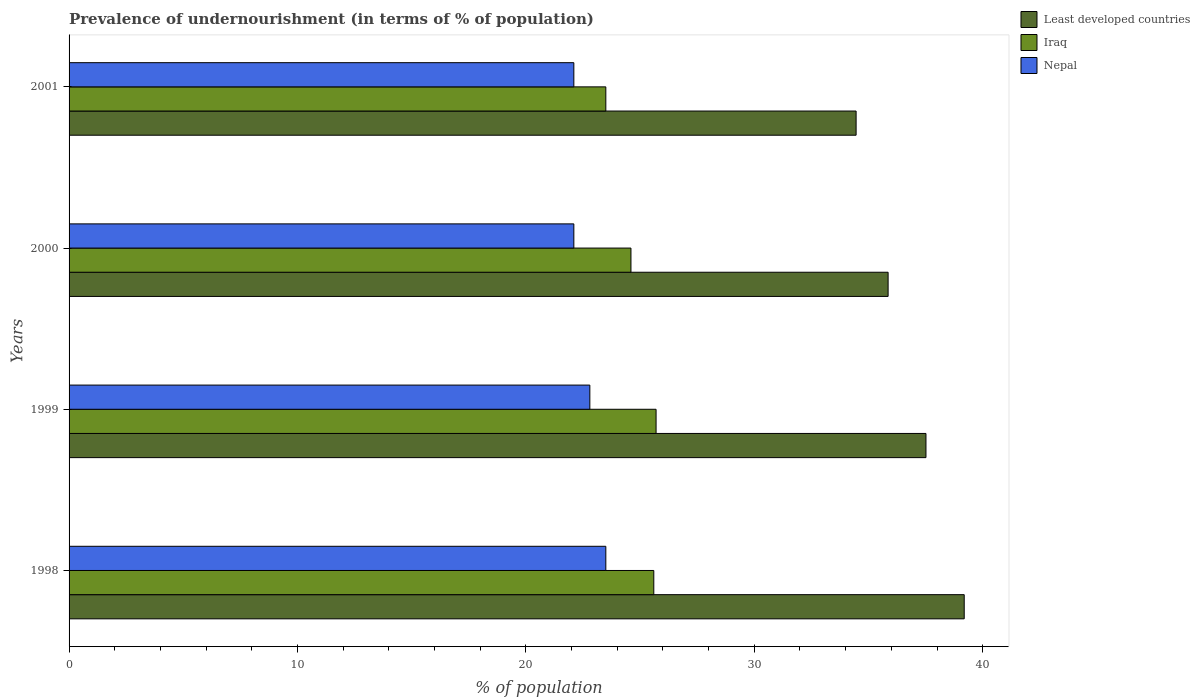Are the number of bars per tick equal to the number of legend labels?
Your answer should be compact. Yes. Are the number of bars on each tick of the Y-axis equal?
Offer a very short reply. Yes. How many bars are there on the 3rd tick from the bottom?
Your answer should be very brief. 3. What is the label of the 1st group of bars from the top?
Your answer should be very brief. 2001. What is the percentage of undernourished population in Iraq in 2000?
Your answer should be very brief. 24.6. Across all years, what is the maximum percentage of undernourished population in Iraq?
Offer a terse response. 25.7. Across all years, what is the minimum percentage of undernourished population in Nepal?
Ensure brevity in your answer.  22.1. What is the total percentage of undernourished population in Least developed countries in the graph?
Keep it short and to the point. 147.02. What is the difference between the percentage of undernourished population in Iraq in 1999 and that in 2000?
Your answer should be compact. 1.1. What is the difference between the percentage of undernourished population in Iraq in 2000 and the percentage of undernourished population in Least developed countries in 1999?
Give a very brief answer. -12.92. What is the average percentage of undernourished population in Nepal per year?
Your response must be concise. 22.62. In the year 1999, what is the difference between the percentage of undernourished population in Nepal and percentage of undernourished population in Iraq?
Make the answer very short. -2.9. What is the ratio of the percentage of undernourished population in Iraq in 1998 to that in 2000?
Your answer should be compact. 1.04. What is the difference between the highest and the second highest percentage of undernourished population in Nepal?
Make the answer very short. 0.7. What is the difference between the highest and the lowest percentage of undernourished population in Iraq?
Provide a short and direct response. 2.2. In how many years, is the percentage of undernourished population in Least developed countries greater than the average percentage of undernourished population in Least developed countries taken over all years?
Make the answer very short. 2. What does the 2nd bar from the top in 2001 represents?
Keep it short and to the point. Iraq. What does the 1st bar from the bottom in 2000 represents?
Offer a terse response. Least developed countries. How many bars are there?
Offer a terse response. 12. Are the values on the major ticks of X-axis written in scientific E-notation?
Your answer should be compact. No. Does the graph contain grids?
Your answer should be compact. No. Where does the legend appear in the graph?
Your response must be concise. Top right. What is the title of the graph?
Give a very brief answer. Prevalence of undernourishment (in terms of % of population). Does "Armenia" appear as one of the legend labels in the graph?
Offer a very short reply. No. What is the label or title of the X-axis?
Provide a short and direct response. % of population. What is the label or title of the Y-axis?
Offer a very short reply. Years. What is the % of population in Least developed countries in 1998?
Provide a short and direct response. 39.19. What is the % of population in Iraq in 1998?
Your answer should be compact. 25.6. What is the % of population in Nepal in 1998?
Make the answer very short. 23.5. What is the % of population in Least developed countries in 1999?
Provide a succinct answer. 37.52. What is the % of population in Iraq in 1999?
Offer a very short reply. 25.7. What is the % of population in Nepal in 1999?
Provide a succinct answer. 22.8. What is the % of population of Least developed countries in 2000?
Provide a succinct answer. 35.86. What is the % of population of Iraq in 2000?
Provide a short and direct response. 24.6. What is the % of population in Nepal in 2000?
Your answer should be very brief. 22.1. What is the % of population in Least developed countries in 2001?
Ensure brevity in your answer.  34.46. What is the % of population in Iraq in 2001?
Keep it short and to the point. 23.5. What is the % of population in Nepal in 2001?
Offer a very short reply. 22.1. Across all years, what is the maximum % of population of Least developed countries?
Keep it short and to the point. 39.19. Across all years, what is the maximum % of population of Iraq?
Offer a very short reply. 25.7. Across all years, what is the maximum % of population of Nepal?
Your response must be concise. 23.5. Across all years, what is the minimum % of population of Least developed countries?
Provide a succinct answer. 34.46. Across all years, what is the minimum % of population of Nepal?
Make the answer very short. 22.1. What is the total % of population of Least developed countries in the graph?
Your answer should be compact. 147.02. What is the total % of population in Iraq in the graph?
Offer a terse response. 99.4. What is the total % of population of Nepal in the graph?
Your answer should be compact. 90.5. What is the difference between the % of population of Least developed countries in 1998 and that in 1999?
Make the answer very short. 1.67. What is the difference between the % of population in Iraq in 1998 and that in 1999?
Offer a very short reply. -0.1. What is the difference between the % of population in Nepal in 1998 and that in 1999?
Your response must be concise. 0.7. What is the difference between the % of population of Least developed countries in 1998 and that in 2000?
Offer a very short reply. 3.33. What is the difference between the % of population of Nepal in 1998 and that in 2000?
Offer a terse response. 1.4. What is the difference between the % of population in Least developed countries in 1998 and that in 2001?
Your answer should be very brief. 4.73. What is the difference between the % of population in Nepal in 1998 and that in 2001?
Offer a very short reply. 1.4. What is the difference between the % of population in Least developed countries in 1999 and that in 2000?
Make the answer very short. 1.66. What is the difference between the % of population of Iraq in 1999 and that in 2000?
Make the answer very short. 1.1. What is the difference between the % of population in Nepal in 1999 and that in 2000?
Provide a succinct answer. 0.7. What is the difference between the % of population of Least developed countries in 1999 and that in 2001?
Your answer should be compact. 3.06. What is the difference between the % of population in Nepal in 1999 and that in 2001?
Offer a terse response. 0.7. What is the difference between the % of population of Least developed countries in 2000 and that in 2001?
Give a very brief answer. 1.4. What is the difference between the % of population in Least developed countries in 1998 and the % of population in Iraq in 1999?
Offer a very short reply. 13.49. What is the difference between the % of population of Least developed countries in 1998 and the % of population of Nepal in 1999?
Keep it short and to the point. 16.39. What is the difference between the % of population of Least developed countries in 1998 and the % of population of Iraq in 2000?
Give a very brief answer. 14.59. What is the difference between the % of population of Least developed countries in 1998 and the % of population of Nepal in 2000?
Provide a succinct answer. 17.09. What is the difference between the % of population of Least developed countries in 1998 and the % of population of Iraq in 2001?
Ensure brevity in your answer.  15.69. What is the difference between the % of population of Least developed countries in 1998 and the % of population of Nepal in 2001?
Give a very brief answer. 17.09. What is the difference between the % of population of Least developed countries in 1999 and the % of population of Iraq in 2000?
Your response must be concise. 12.92. What is the difference between the % of population in Least developed countries in 1999 and the % of population in Nepal in 2000?
Your answer should be very brief. 15.42. What is the difference between the % of population of Least developed countries in 1999 and the % of population of Iraq in 2001?
Provide a succinct answer. 14.02. What is the difference between the % of population of Least developed countries in 1999 and the % of population of Nepal in 2001?
Make the answer very short. 15.42. What is the difference between the % of population of Least developed countries in 2000 and the % of population of Iraq in 2001?
Make the answer very short. 12.36. What is the difference between the % of population in Least developed countries in 2000 and the % of population in Nepal in 2001?
Provide a short and direct response. 13.76. What is the average % of population in Least developed countries per year?
Make the answer very short. 36.76. What is the average % of population of Iraq per year?
Make the answer very short. 24.85. What is the average % of population of Nepal per year?
Offer a terse response. 22.62. In the year 1998, what is the difference between the % of population of Least developed countries and % of population of Iraq?
Make the answer very short. 13.59. In the year 1998, what is the difference between the % of population of Least developed countries and % of population of Nepal?
Your answer should be very brief. 15.69. In the year 1999, what is the difference between the % of population in Least developed countries and % of population in Iraq?
Provide a short and direct response. 11.82. In the year 1999, what is the difference between the % of population in Least developed countries and % of population in Nepal?
Provide a short and direct response. 14.72. In the year 1999, what is the difference between the % of population in Iraq and % of population in Nepal?
Offer a terse response. 2.9. In the year 2000, what is the difference between the % of population of Least developed countries and % of population of Iraq?
Ensure brevity in your answer.  11.26. In the year 2000, what is the difference between the % of population in Least developed countries and % of population in Nepal?
Provide a short and direct response. 13.76. In the year 2000, what is the difference between the % of population of Iraq and % of population of Nepal?
Offer a very short reply. 2.5. In the year 2001, what is the difference between the % of population in Least developed countries and % of population in Iraq?
Your response must be concise. 10.96. In the year 2001, what is the difference between the % of population of Least developed countries and % of population of Nepal?
Ensure brevity in your answer.  12.36. In the year 2001, what is the difference between the % of population in Iraq and % of population in Nepal?
Keep it short and to the point. 1.4. What is the ratio of the % of population in Least developed countries in 1998 to that in 1999?
Your response must be concise. 1.04. What is the ratio of the % of population in Iraq in 1998 to that in 1999?
Make the answer very short. 1. What is the ratio of the % of population of Nepal in 1998 to that in 1999?
Your response must be concise. 1.03. What is the ratio of the % of population of Least developed countries in 1998 to that in 2000?
Offer a very short reply. 1.09. What is the ratio of the % of population of Iraq in 1998 to that in 2000?
Make the answer very short. 1.04. What is the ratio of the % of population in Nepal in 1998 to that in 2000?
Your answer should be compact. 1.06. What is the ratio of the % of population of Least developed countries in 1998 to that in 2001?
Ensure brevity in your answer.  1.14. What is the ratio of the % of population in Iraq in 1998 to that in 2001?
Ensure brevity in your answer.  1.09. What is the ratio of the % of population of Nepal in 1998 to that in 2001?
Ensure brevity in your answer.  1.06. What is the ratio of the % of population of Least developed countries in 1999 to that in 2000?
Offer a terse response. 1.05. What is the ratio of the % of population of Iraq in 1999 to that in 2000?
Your answer should be compact. 1.04. What is the ratio of the % of population in Nepal in 1999 to that in 2000?
Keep it short and to the point. 1.03. What is the ratio of the % of population of Least developed countries in 1999 to that in 2001?
Your response must be concise. 1.09. What is the ratio of the % of population of Iraq in 1999 to that in 2001?
Give a very brief answer. 1.09. What is the ratio of the % of population of Nepal in 1999 to that in 2001?
Ensure brevity in your answer.  1.03. What is the ratio of the % of population of Least developed countries in 2000 to that in 2001?
Provide a succinct answer. 1.04. What is the ratio of the % of population in Iraq in 2000 to that in 2001?
Your response must be concise. 1.05. What is the ratio of the % of population in Nepal in 2000 to that in 2001?
Offer a very short reply. 1. What is the difference between the highest and the second highest % of population of Least developed countries?
Provide a succinct answer. 1.67. What is the difference between the highest and the second highest % of population in Iraq?
Your response must be concise. 0.1. What is the difference between the highest and the lowest % of population of Least developed countries?
Ensure brevity in your answer.  4.73. What is the difference between the highest and the lowest % of population of Nepal?
Your answer should be compact. 1.4. 